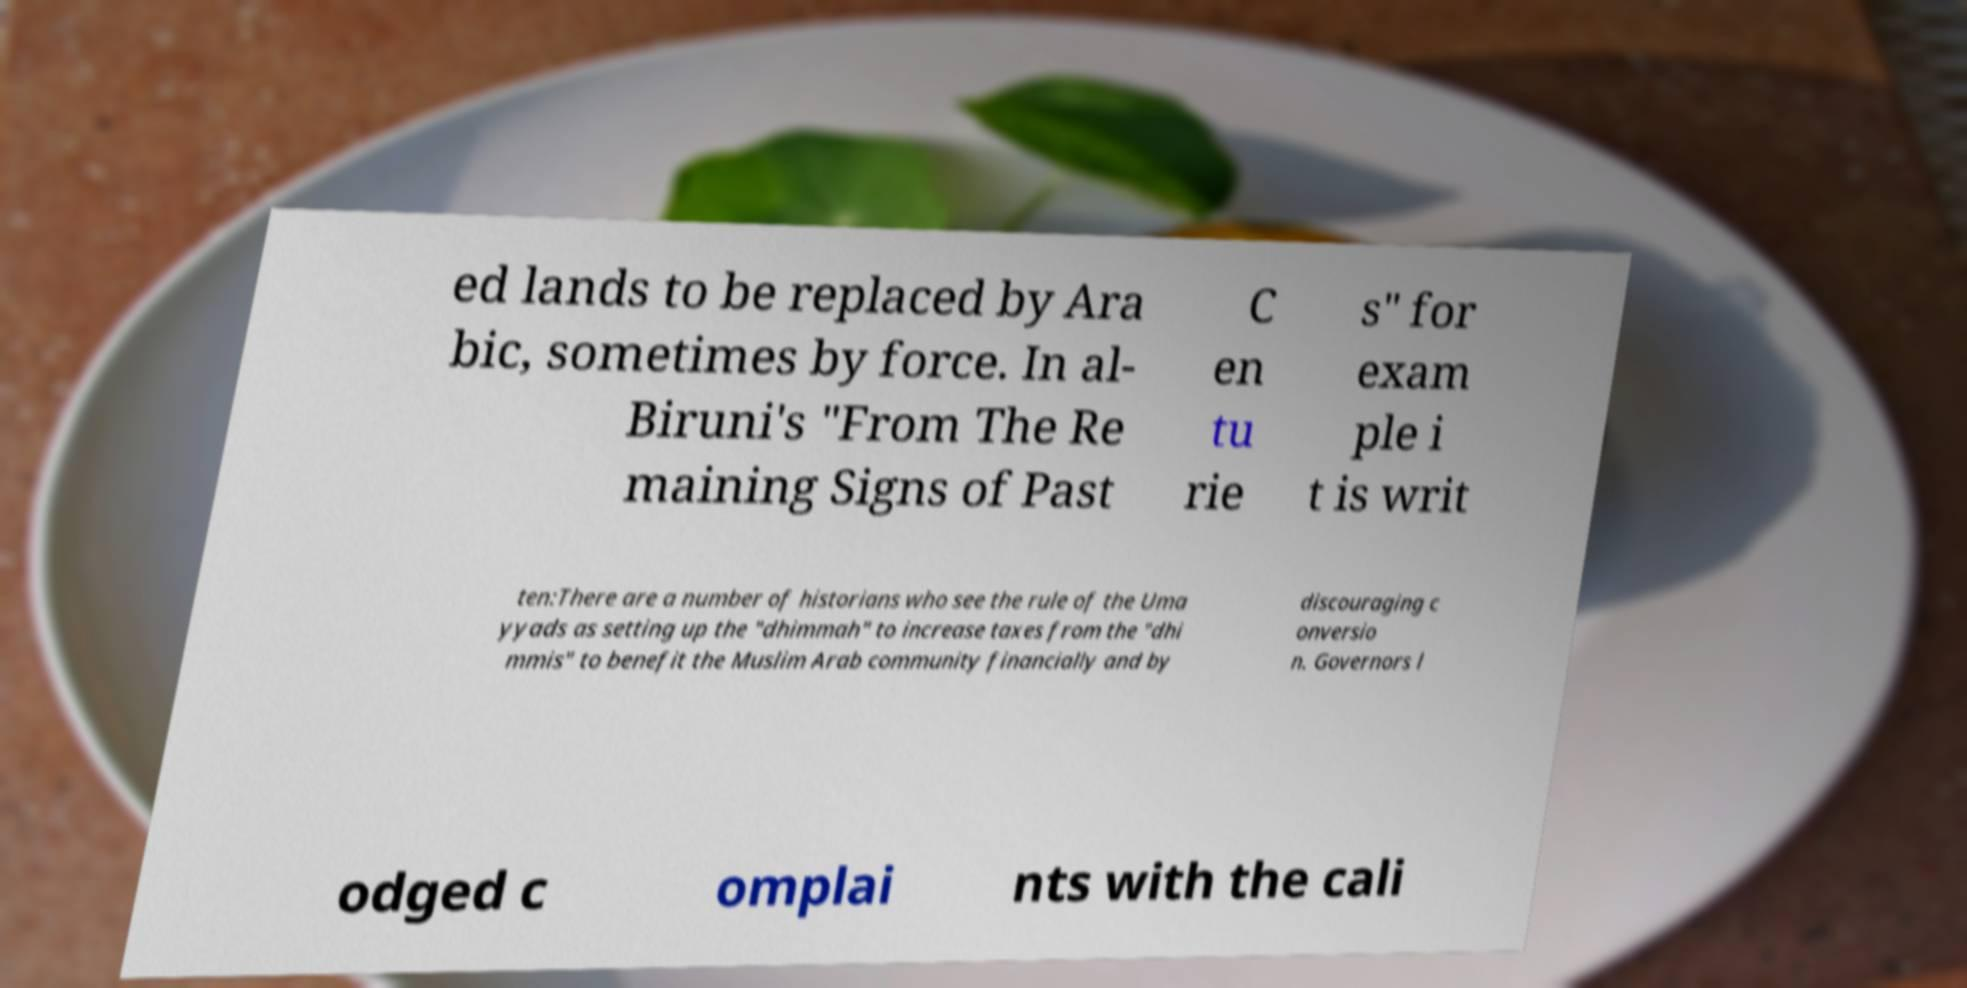Please identify and transcribe the text found in this image. ed lands to be replaced by Ara bic, sometimes by force. In al- Biruni's "From The Re maining Signs of Past C en tu rie s" for exam ple i t is writ ten:There are a number of historians who see the rule of the Uma yyads as setting up the "dhimmah" to increase taxes from the "dhi mmis" to benefit the Muslim Arab community financially and by discouraging c onversio n. Governors l odged c omplai nts with the cali 